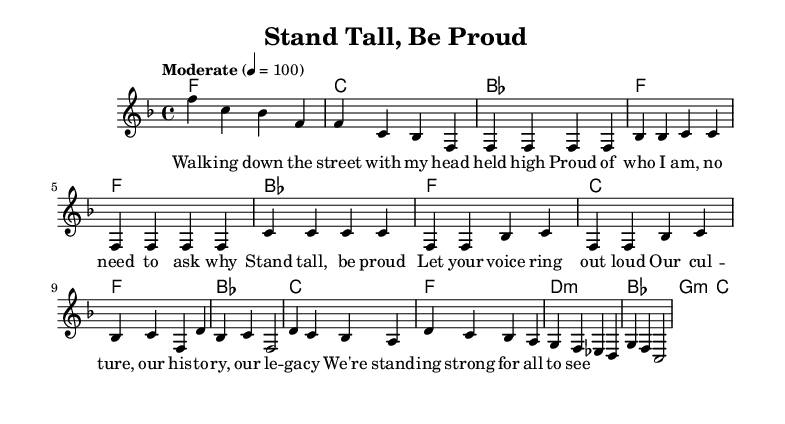What is the key signature of this music? The key signature is F major, which has one flat (B flat). This can be determined by looking at the key signature at the beginning of the score, which shows the flat.
Answer: F major What is the time signature of this music? The time signature is 4/4, as indicated at the beginning of the score. This means there are four beats in a measure, and the quarter note gets one beat.
Answer: 4/4 What is the tempo marking given for the piece? The tempo marking is "Moderate" with a metronomic value of 100 beats per minute. This is specified in the tempo indication located at the beginning of the sheet music.
Answer: Moderate 100 How many bars are there in the chorus section? The chorus section consists of 4 bars. This can be counted directly from the score section labeled as "Chorus," which contains the measures.
Answer: 4 How many times does the word "proud" appear in the lyrics? The word "proud" appears 2 times in the lyrics. This can be verified by reading through the lyrics and counting each occurrence of the word.
Answer: 2 What is the chord progression for the verse? The chord progression for the verse is F, B flat, F, C. This can be deduced by looking at the "Verse" section in the harmonies, which shows these chords aligned with the measures.
Answer: F, B flat, F, C What message does the chorus convey in terms of cultural identity? The chorus emphasizes strength and pride in cultural heritage. It expresses the importance of standing tall and celebrating identity, as seen in the lyrics “Stand tall, be proud” and references to culture and history.
Answer: Strength and pride 